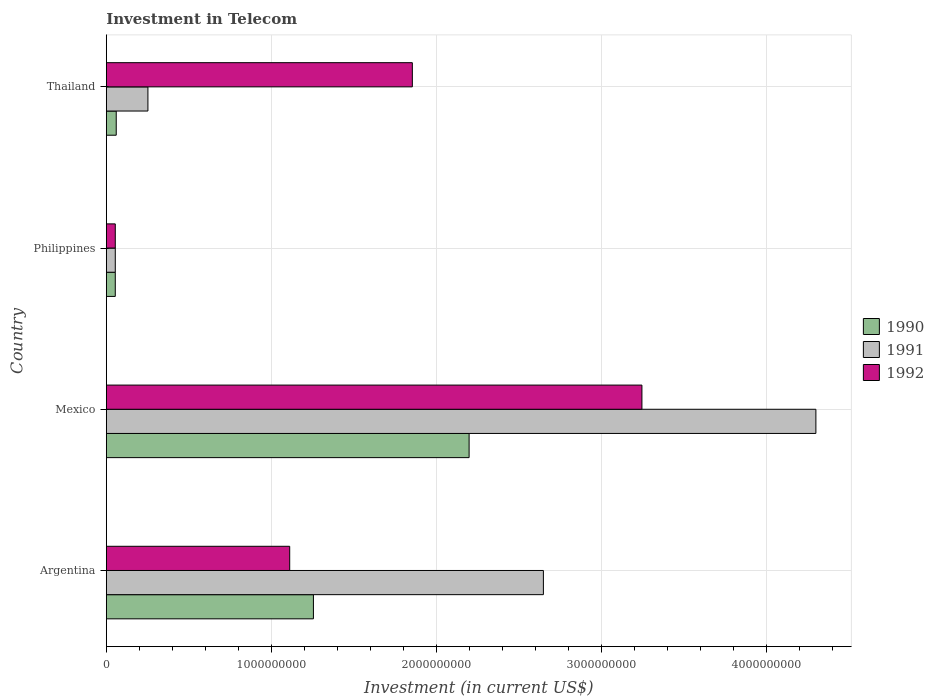How many different coloured bars are there?
Offer a terse response. 3. How many bars are there on the 1st tick from the bottom?
Provide a succinct answer. 3. What is the label of the 2nd group of bars from the top?
Your answer should be compact. Philippines. In how many cases, is the number of bars for a given country not equal to the number of legend labels?
Provide a succinct answer. 0. What is the amount invested in telecom in 1992 in Philippines?
Offer a terse response. 5.42e+07. Across all countries, what is the maximum amount invested in telecom in 1992?
Offer a terse response. 3.24e+09. Across all countries, what is the minimum amount invested in telecom in 1991?
Ensure brevity in your answer.  5.42e+07. What is the total amount invested in telecom in 1990 in the graph?
Keep it short and to the point. 3.57e+09. What is the difference between the amount invested in telecom in 1992 in Argentina and that in Philippines?
Your answer should be very brief. 1.06e+09. What is the difference between the amount invested in telecom in 1991 in Argentina and the amount invested in telecom in 1990 in Thailand?
Offer a terse response. 2.59e+09. What is the average amount invested in telecom in 1992 per country?
Give a very brief answer. 1.57e+09. What is the difference between the amount invested in telecom in 1990 and amount invested in telecom in 1991 in Mexico?
Make the answer very short. -2.10e+09. What is the ratio of the amount invested in telecom in 1992 in Argentina to that in Thailand?
Make the answer very short. 0.6. Is the amount invested in telecom in 1990 in Philippines less than that in Thailand?
Provide a succinct answer. Yes. Is the difference between the amount invested in telecom in 1990 in Argentina and Philippines greater than the difference between the amount invested in telecom in 1991 in Argentina and Philippines?
Your answer should be compact. No. What is the difference between the highest and the second highest amount invested in telecom in 1990?
Give a very brief answer. 9.43e+08. What is the difference between the highest and the lowest amount invested in telecom in 1991?
Your answer should be compact. 4.24e+09. Is the sum of the amount invested in telecom in 1992 in Mexico and Philippines greater than the maximum amount invested in telecom in 1991 across all countries?
Make the answer very short. No. Is it the case that in every country, the sum of the amount invested in telecom in 1991 and amount invested in telecom in 1992 is greater than the amount invested in telecom in 1990?
Give a very brief answer. Yes. How many bars are there?
Keep it short and to the point. 12. Are all the bars in the graph horizontal?
Ensure brevity in your answer.  Yes. How many countries are there in the graph?
Your answer should be very brief. 4. Are the values on the major ticks of X-axis written in scientific E-notation?
Provide a short and direct response. No. How many legend labels are there?
Your answer should be compact. 3. What is the title of the graph?
Provide a short and direct response. Investment in Telecom. Does "1985" appear as one of the legend labels in the graph?
Make the answer very short. No. What is the label or title of the X-axis?
Your response must be concise. Investment (in current US$). What is the Investment (in current US$) in 1990 in Argentina?
Make the answer very short. 1.25e+09. What is the Investment (in current US$) of 1991 in Argentina?
Your response must be concise. 2.65e+09. What is the Investment (in current US$) in 1992 in Argentina?
Keep it short and to the point. 1.11e+09. What is the Investment (in current US$) in 1990 in Mexico?
Make the answer very short. 2.20e+09. What is the Investment (in current US$) of 1991 in Mexico?
Provide a succinct answer. 4.30e+09. What is the Investment (in current US$) of 1992 in Mexico?
Make the answer very short. 3.24e+09. What is the Investment (in current US$) of 1990 in Philippines?
Provide a short and direct response. 5.42e+07. What is the Investment (in current US$) in 1991 in Philippines?
Provide a short and direct response. 5.42e+07. What is the Investment (in current US$) of 1992 in Philippines?
Provide a succinct answer. 5.42e+07. What is the Investment (in current US$) of 1990 in Thailand?
Offer a very short reply. 6.00e+07. What is the Investment (in current US$) of 1991 in Thailand?
Offer a terse response. 2.52e+08. What is the Investment (in current US$) of 1992 in Thailand?
Offer a very short reply. 1.85e+09. Across all countries, what is the maximum Investment (in current US$) in 1990?
Offer a very short reply. 2.20e+09. Across all countries, what is the maximum Investment (in current US$) in 1991?
Give a very brief answer. 4.30e+09. Across all countries, what is the maximum Investment (in current US$) of 1992?
Make the answer very short. 3.24e+09. Across all countries, what is the minimum Investment (in current US$) in 1990?
Your answer should be compact. 5.42e+07. Across all countries, what is the minimum Investment (in current US$) of 1991?
Your answer should be very brief. 5.42e+07. Across all countries, what is the minimum Investment (in current US$) of 1992?
Your response must be concise. 5.42e+07. What is the total Investment (in current US$) in 1990 in the graph?
Offer a terse response. 3.57e+09. What is the total Investment (in current US$) in 1991 in the graph?
Keep it short and to the point. 7.25e+09. What is the total Investment (in current US$) in 1992 in the graph?
Make the answer very short. 6.26e+09. What is the difference between the Investment (in current US$) of 1990 in Argentina and that in Mexico?
Your response must be concise. -9.43e+08. What is the difference between the Investment (in current US$) in 1991 in Argentina and that in Mexico?
Provide a succinct answer. -1.65e+09. What is the difference between the Investment (in current US$) in 1992 in Argentina and that in Mexico?
Make the answer very short. -2.13e+09. What is the difference between the Investment (in current US$) in 1990 in Argentina and that in Philippines?
Your answer should be very brief. 1.20e+09. What is the difference between the Investment (in current US$) in 1991 in Argentina and that in Philippines?
Give a very brief answer. 2.59e+09. What is the difference between the Investment (in current US$) of 1992 in Argentina and that in Philippines?
Your answer should be very brief. 1.06e+09. What is the difference between the Investment (in current US$) of 1990 in Argentina and that in Thailand?
Give a very brief answer. 1.19e+09. What is the difference between the Investment (in current US$) in 1991 in Argentina and that in Thailand?
Your answer should be compact. 2.40e+09. What is the difference between the Investment (in current US$) in 1992 in Argentina and that in Thailand?
Your answer should be compact. -7.43e+08. What is the difference between the Investment (in current US$) of 1990 in Mexico and that in Philippines?
Offer a terse response. 2.14e+09. What is the difference between the Investment (in current US$) of 1991 in Mexico and that in Philippines?
Make the answer very short. 4.24e+09. What is the difference between the Investment (in current US$) of 1992 in Mexico and that in Philippines?
Keep it short and to the point. 3.19e+09. What is the difference between the Investment (in current US$) in 1990 in Mexico and that in Thailand?
Your response must be concise. 2.14e+09. What is the difference between the Investment (in current US$) in 1991 in Mexico and that in Thailand?
Ensure brevity in your answer.  4.05e+09. What is the difference between the Investment (in current US$) in 1992 in Mexico and that in Thailand?
Give a very brief answer. 1.39e+09. What is the difference between the Investment (in current US$) in 1990 in Philippines and that in Thailand?
Your response must be concise. -5.80e+06. What is the difference between the Investment (in current US$) of 1991 in Philippines and that in Thailand?
Keep it short and to the point. -1.98e+08. What is the difference between the Investment (in current US$) in 1992 in Philippines and that in Thailand?
Provide a succinct answer. -1.80e+09. What is the difference between the Investment (in current US$) in 1990 in Argentina and the Investment (in current US$) in 1991 in Mexico?
Keep it short and to the point. -3.04e+09. What is the difference between the Investment (in current US$) of 1990 in Argentina and the Investment (in current US$) of 1992 in Mexico?
Your answer should be compact. -1.99e+09. What is the difference between the Investment (in current US$) of 1991 in Argentina and the Investment (in current US$) of 1992 in Mexico?
Your response must be concise. -5.97e+08. What is the difference between the Investment (in current US$) of 1990 in Argentina and the Investment (in current US$) of 1991 in Philippines?
Make the answer very short. 1.20e+09. What is the difference between the Investment (in current US$) of 1990 in Argentina and the Investment (in current US$) of 1992 in Philippines?
Your response must be concise. 1.20e+09. What is the difference between the Investment (in current US$) in 1991 in Argentina and the Investment (in current US$) in 1992 in Philippines?
Your response must be concise. 2.59e+09. What is the difference between the Investment (in current US$) in 1990 in Argentina and the Investment (in current US$) in 1991 in Thailand?
Give a very brief answer. 1.00e+09. What is the difference between the Investment (in current US$) of 1990 in Argentina and the Investment (in current US$) of 1992 in Thailand?
Your answer should be very brief. -5.99e+08. What is the difference between the Investment (in current US$) in 1991 in Argentina and the Investment (in current US$) in 1992 in Thailand?
Ensure brevity in your answer.  7.94e+08. What is the difference between the Investment (in current US$) of 1990 in Mexico and the Investment (in current US$) of 1991 in Philippines?
Your answer should be compact. 2.14e+09. What is the difference between the Investment (in current US$) in 1990 in Mexico and the Investment (in current US$) in 1992 in Philippines?
Keep it short and to the point. 2.14e+09. What is the difference between the Investment (in current US$) in 1991 in Mexico and the Investment (in current US$) in 1992 in Philippines?
Offer a very short reply. 4.24e+09. What is the difference between the Investment (in current US$) of 1990 in Mexico and the Investment (in current US$) of 1991 in Thailand?
Give a very brief answer. 1.95e+09. What is the difference between the Investment (in current US$) in 1990 in Mexico and the Investment (in current US$) in 1992 in Thailand?
Ensure brevity in your answer.  3.44e+08. What is the difference between the Investment (in current US$) of 1991 in Mexico and the Investment (in current US$) of 1992 in Thailand?
Your answer should be very brief. 2.44e+09. What is the difference between the Investment (in current US$) of 1990 in Philippines and the Investment (in current US$) of 1991 in Thailand?
Your answer should be compact. -1.98e+08. What is the difference between the Investment (in current US$) in 1990 in Philippines and the Investment (in current US$) in 1992 in Thailand?
Provide a short and direct response. -1.80e+09. What is the difference between the Investment (in current US$) of 1991 in Philippines and the Investment (in current US$) of 1992 in Thailand?
Your answer should be very brief. -1.80e+09. What is the average Investment (in current US$) in 1990 per country?
Give a very brief answer. 8.92e+08. What is the average Investment (in current US$) in 1991 per country?
Ensure brevity in your answer.  1.81e+09. What is the average Investment (in current US$) of 1992 per country?
Provide a succinct answer. 1.57e+09. What is the difference between the Investment (in current US$) of 1990 and Investment (in current US$) of 1991 in Argentina?
Your answer should be compact. -1.39e+09. What is the difference between the Investment (in current US$) of 1990 and Investment (in current US$) of 1992 in Argentina?
Your response must be concise. 1.44e+08. What is the difference between the Investment (in current US$) in 1991 and Investment (in current US$) in 1992 in Argentina?
Offer a terse response. 1.54e+09. What is the difference between the Investment (in current US$) of 1990 and Investment (in current US$) of 1991 in Mexico?
Provide a short and direct response. -2.10e+09. What is the difference between the Investment (in current US$) in 1990 and Investment (in current US$) in 1992 in Mexico?
Make the answer very short. -1.05e+09. What is the difference between the Investment (in current US$) of 1991 and Investment (in current US$) of 1992 in Mexico?
Offer a terse response. 1.05e+09. What is the difference between the Investment (in current US$) of 1990 and Investment (in current US$) of 1991 in Philippines?
Make the answer very short. 0. What is the difference between the Investment (in current US$) of 1990 and Investment (in current US$) of 1992 in Philippines?
Make the answer very short. 0. What is the difference between the Investment (in current US$) of 1990 and Investment (in current US$) of 1991 in Thailand?
Your answer should be very brief. -1.92e+08. What is the difference between the Investment (in current US$) in 1990 and Investment (in current US$) in 1992 in Thailand?
Your answer should be very brief. -1.79e+09. What is the difference between the Investment (in current US$) in 1991 and Investment (in current US$) in 1992 in Thailand?
Make the answer very short. -1.60e+09. What is the ratio of the Investment (in current US$) of 1990 in Argentina to that in Mexico?
Provide a succinct answer. 0.57. What is the ratio of the Investment (in current US$) in 1991 in Argentina to that in Mexico?
Make the answer very short. 0.62. What is the ratio of the Investment (in current US$) in 1992 in Argentina to that in Mexico?
Provide a short and direct response. 0.34. What is the ratio of the Investment (in current US$) of 1990 in Argentina to that in Philippines?
Your response must be concise. 23.15. What is the ratio of the Investment (in current US$) in 1991 in Argentina to that in Philippines?
Provide a short and direct response. 48.86. What is the ratio of the Investment (in current US$) in 1992 in Argentina to that in Philippines?
Provide a succinct answer. 20.5. What is the ratio of the Investment (in current US$) of 1990 in Argentina to that in Thailand?
Ensure brevity in your answer.  20.91. What is the ratio of the Investment (in current US$) of 1991 in Argentina to that in Thailand?
Your answer should be compact. 10.51. What is the ratio of the Investment (in current US$) of 1992 in Argentina to that in Thailand?
Offer a terse response. 0.6. What is the ratio of the Investment (in current US$) of 1990 in Mexico to that in Philippines?
Offer a terse response. 40.55. What is the ratio of the Investment (in current US$) in 1991 in Mexico to that in Philippines?
Keep it short and to the point. 79.32. What is the ratio of the Investment (in current US$) of 1992 in Mexico to that in Philippines?
Ensure brevity in your answer.  59.87. What is the ratio of the Investment (in current US$) of 1990 in Mexico to that in Thailand?
Your answer should be compact. 36.63. What is the ratio of the Investment (in current US$) of 1991 in Mexico to that in Thailand?
Give a very brief answer. 17.06. What is the ratio of the Investment (in current US$) in 1992 in Mexico to that in Thailand?
Your answer should be very brief. 1.75. What is the ratio of the Investment (in current US$) of 1990 in Philippines to that in Thailand?
Your response must be concise. 0.9. What is the ratio of the Investment (in current US$) in 1991 in Philippines to that in Thailand?
Offer a very short reply. 0.22. What is the ratio of the Investment (in current US$) of 1992 in Philippines to that in Thailand?
Provide a succinct answer. 0.03. What is the difference between the highest and the second highest Investment (in current US$) of 1990?
Your answer should be compact. 9.43e+08. What is the difference between the highest and the second highest Investment (in current US$) of 1991?
Offer a terse response. 1.65e+09. What is the difference between the highest and the second highest Investment (in current US$) in 1992?
Keep it short and to the point. 1.39e+09. What is the difference between the highest and the lowest Investment (in current US$) in 1990?
Keep it short and to the point. 2.14e+09. What is the difference between the highest and the lowest Investment (in current US$) in 1991?
Provide a succinct answer. 4.24e+09. What is the difference between the highest and the lowest Investment (in current US$) of 1992?
Provide a succinct answer. 3.19e+09. 